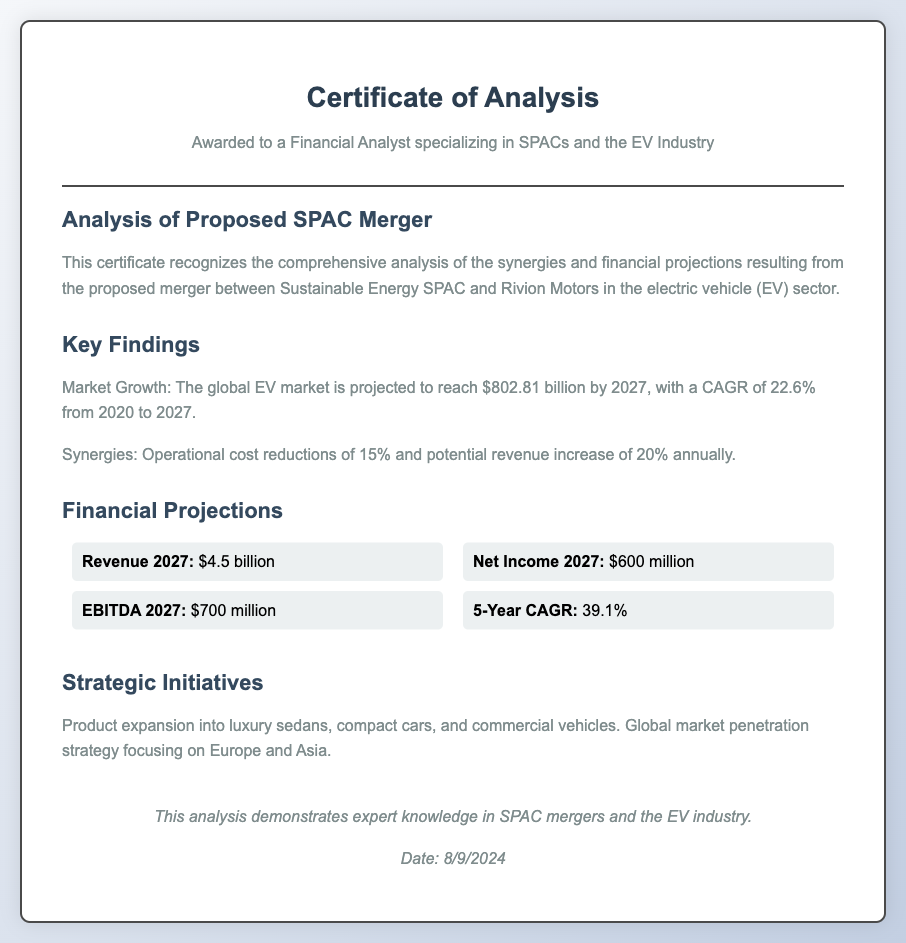What is the title of the diploma? The title of the diploma is presented at the top of the document, which is "Certificate of Analysis".
Answer: Certificate of Analysis What company is involved in the SPAC merger? The company mentioned in the proposed merger is "Rivion Motors".
Answer: Rivion Motors What is the projected revenue for 2027? The projected revenue can be found in the financial projections section, which states it is "$4.5 billion".
Answer: $4.5 billion What is the expected EBITDA for 2027? The expected EBITDA is listed in the financial data as "$700 million".
Answer: $700 million What is the projected CAGR from 2020 to 2027? The compound annual growth rate (CAGR) for the specified period is mentioned as "22.6%".
Answer: 22.6% How much are operational cost reductions expected to be? The document states that operational cost reductions are estimated at "15%".
Answer: 15% What is the net income projection for 2027? The net income projection for 2027 is provided as "$600 million".
Answer: $600 million What strategic market focuses are mentioned? The strategic market focuses identified are "Europe and Asia".
Answer: Europe and Asia 